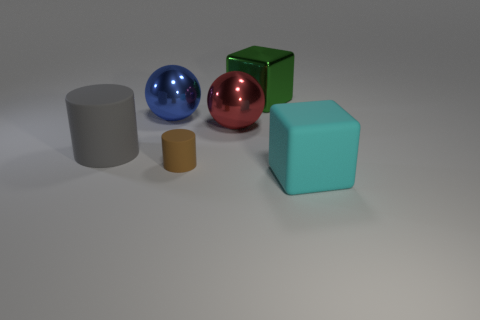Is the material of the large block behind the blue metallic ball the same as the cyan cube?
Your answer should be very brief. No. The large matte object right of the large shiny block has what shape?
Provide a short and direct response. Cube. There is a cyan object that is the same size as the red ball; what is it made of?
Provide a short and direct response. Rubber. How many things are large blocks that are behind the brown cylinder or matte things behind the big cyan block?
Keep it short and to the point. 3. There is a block that is made of the same material as the gray cylinder; what size is it?
Provide a short and direct response. Large. Do the red ball and the blue sphere have the same size?
Offer a terse response. Yes. What is the material of the big block that is behind the cyan rubber block?
Make the answer very short. Metal. What is the material of the other object that is the same shape as the tiny brown thing?
Provide a succinct answer. Rubber. Is there a matte cylinder to the left of the cylinder that is behind the brown thing?
Keep it short and to the point. No. Is the shape of the large gray thing the same as the red thing?
Your response must be concise. No. 